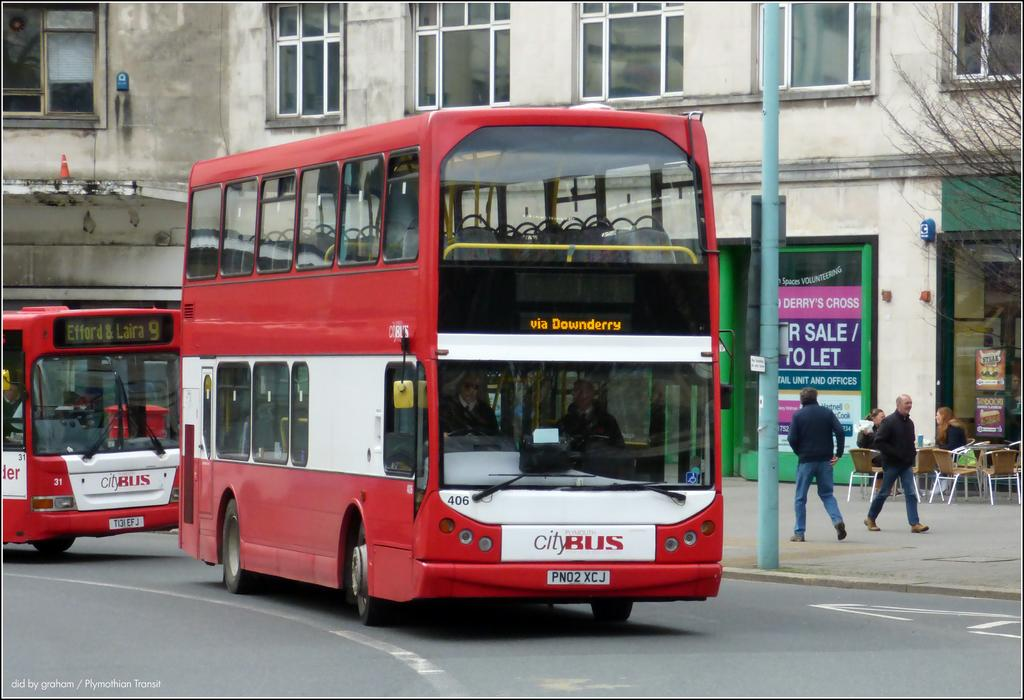<image>
Describe the image concisely. a bus with a label that says 'plymouth city bus' on the front of it 